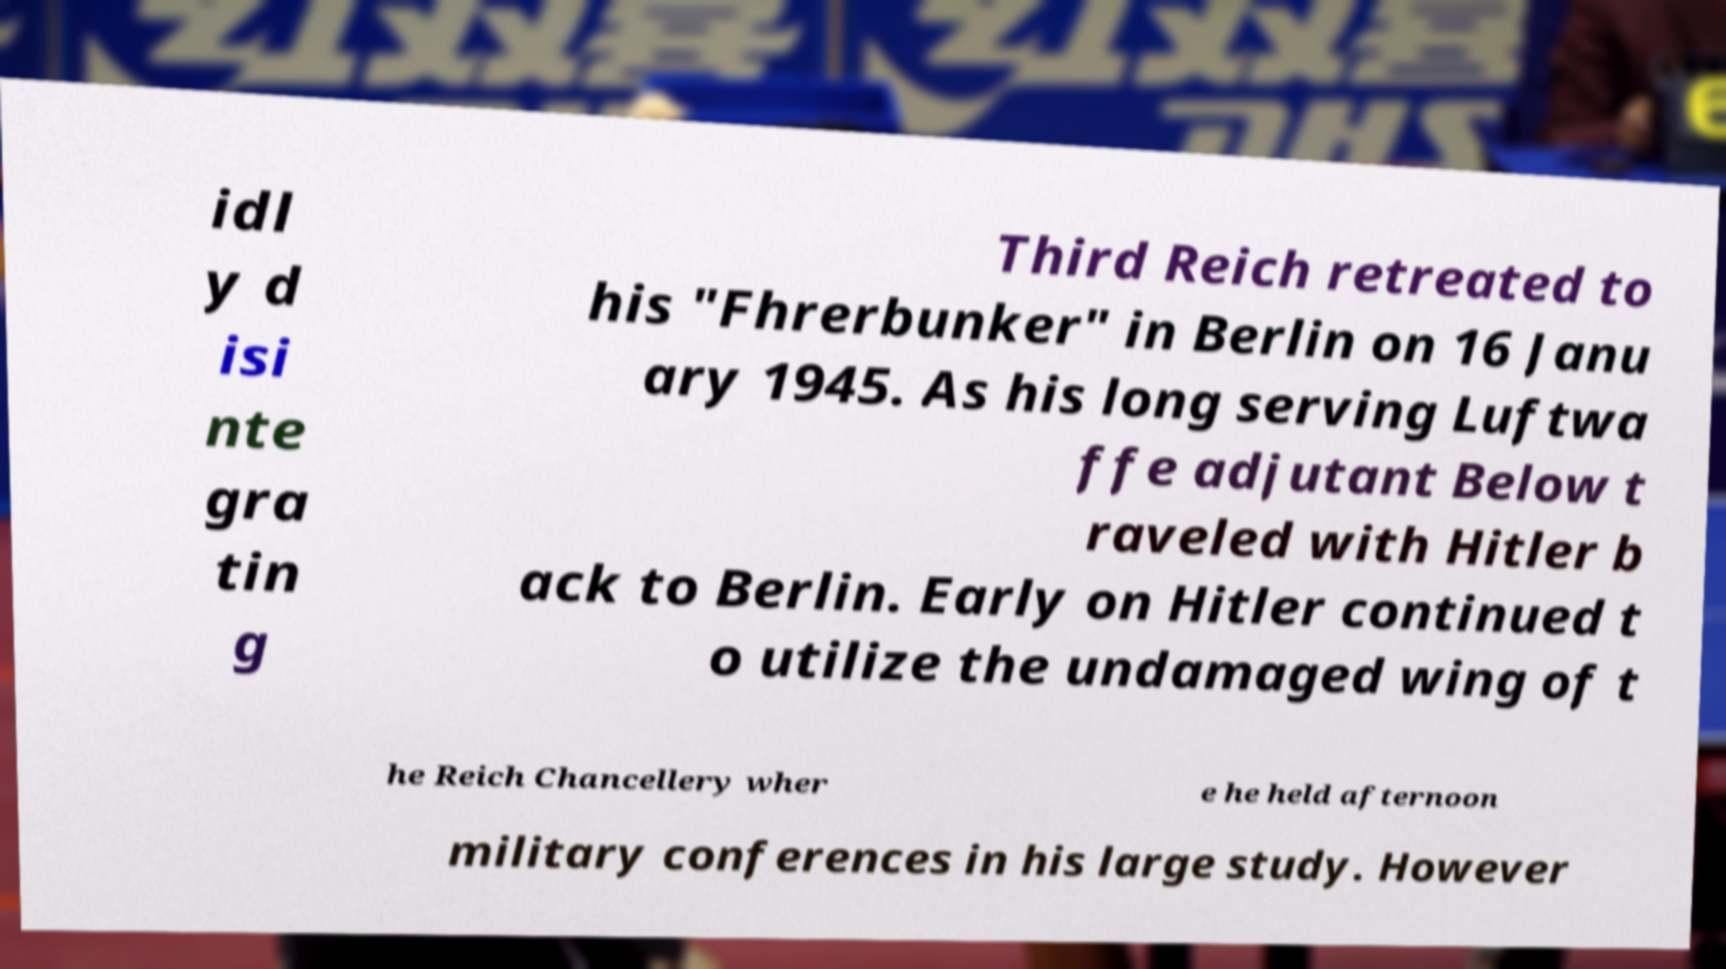Can you read and provide the text displayed in the image?This photo seems to have some interesting text. Can you extract and type it out for me? idl y d isi nte gra tin g Third Reich retreated to his "Fhrerbunker" in Berlin on 16 Janu ary 1945. As his long serving Luftwa ffe adjutant Below t raveled with Hitler b ack to Berlin. Early on Hitler continued t o utilize the undamaged wing of t he Reich Chancellery wher e he held afternoon military conferences in his large study. However 